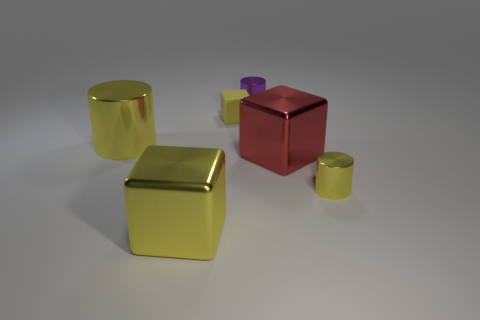What is the shape of the small metal thing that is the same color as the big metallic cylinder?
Your response must be concise. Cylinder. There is a cylinder that is on the left side of the small purple thing; does it have the same color as the metal thing that is to the right of the red metal thing?
Provide a succinct answer. Yes. Are there any blocks made of the same material as the red thing?
Give a very brief answer. Yes. Are the tiny thing that is in front of the large yellow cylinder and the large yellow cylinder made of the same material?
Ensure brevity in your answer.  Yes. What is the size of the shiny object that is behind the tiny yellow cylinder and to the left of the purple metal cylinder?
Make the answer very short. Large. The large shiny cylinder has what color?
Provide a succinct answer. Yellow. How many tiny purple cylinders are there?
Ensure brevity in your answer.  1. What number of big cylinders have the same color as the small cube?
Give a very brief answer. 1. Do the tiny metal thing that is in front of the purple cylinder and the big yellow metallic thing behind the small yellow metal object have the same shape?
Make the answer very short. Yes. What color is the tiny metal object in front of the shiny cube right of the yellow block on the left side of the tiny rubber thing?
Your answer should be compact. Yellow. 